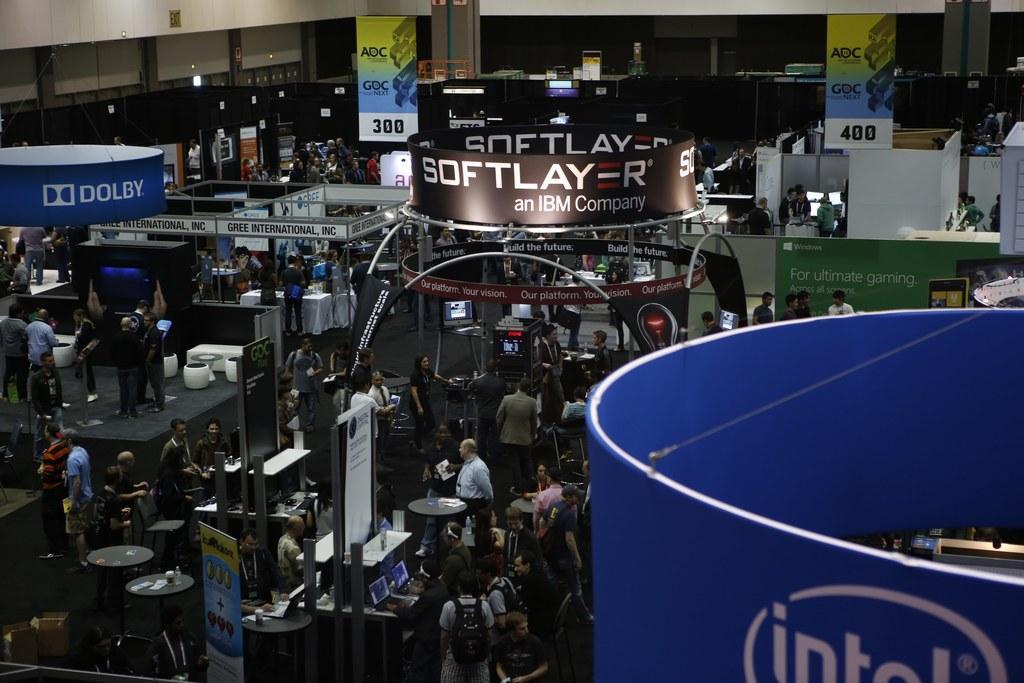Describe this image in one or two sentences. In this image in the center there are persons standing and there are banners with some text written on it, and there are monitors, keyboard, tables. In the background there are banners with some text on it and there is a wall. 